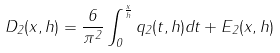<formula> <loc_0><loc_0><loc_500><loc_500>D _ { 2 } ( x , h ) = \frac { 6 } { \pi ^ { 2 } } \int _ { 0 } ^ { \frac { x } { h } } q _ { 2 } ( t , h ) d t + E _ { 2 } ( x , h )</formula> 